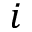Convert formula to latex. <formula><loc_0><loc_0><loc_500><loc_500>i</formula> 